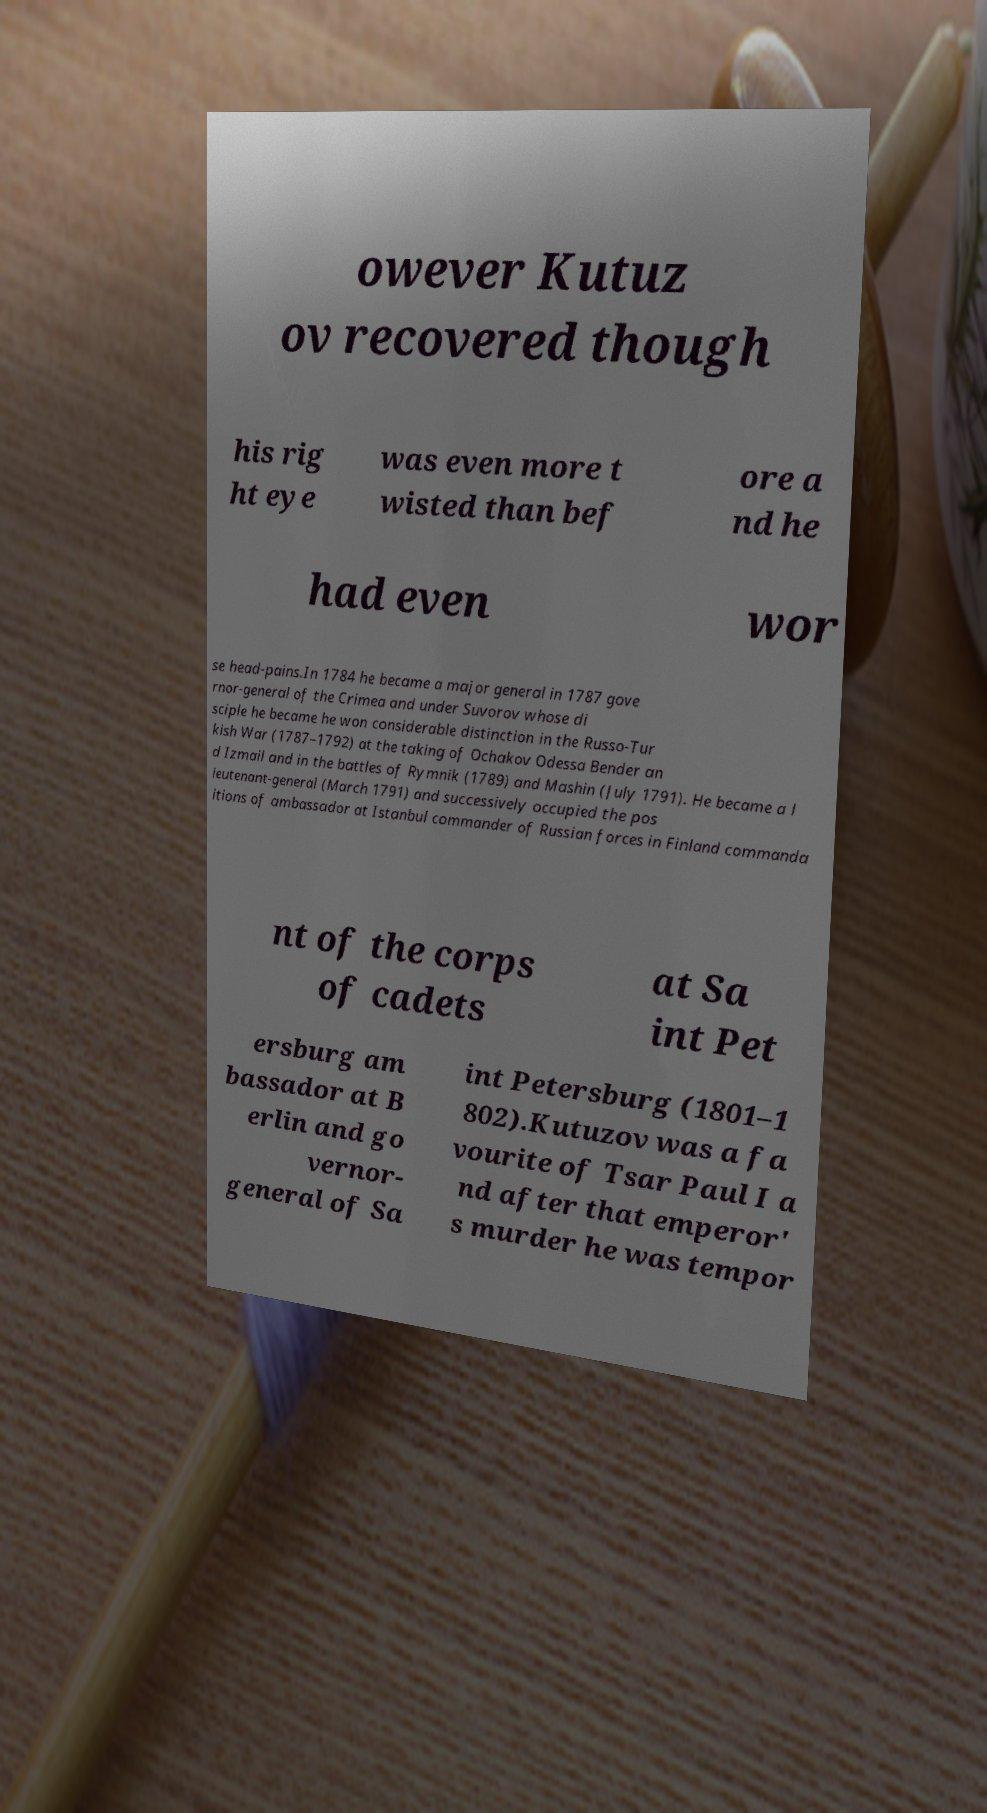Please identify and transcribe the text found in this image. owever Kutuz ov recovered though his rig ht eye was even more t wisted than bef ore a nd he had even wor se head-pains.In 1784 he became a major general in 1787 gove rnor-general of the Crimea and under Suvorov whose di sciple he became he won considerable distinction in the Russo-Tur kish War (1787–1792) at the taking of Ochakov Odessa Bender an d Izmail and in the battles of Rymnik (1789) and Mashin (July 1791). He became a l ieutenant-general (March 1791) and successively occupied the pos itions of ambassador at Istanbul commander of Russian forces in Finland commanda nt of the corps of cadets at Sa int Pet ersburg am bassador at B erlin and go vernor- general of Sa int Petersburg (1801–1 802).Kutuzov was a fa vourite of Tsar Paul I a nd after that emperor' s murder he was tempor 